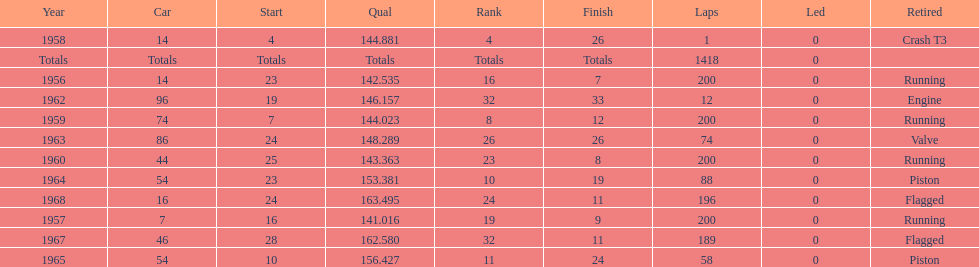How long did bob veith have the number 54 car at the indy 500? 2 years. 